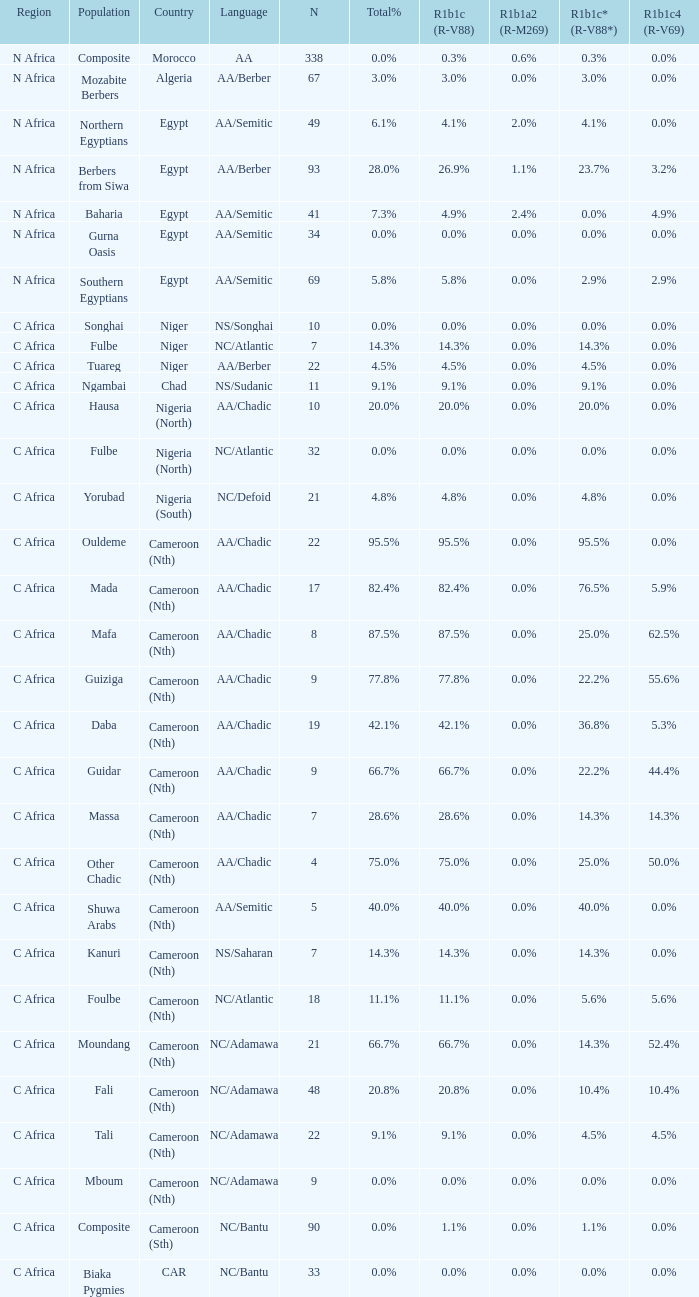What is the number of n listed for berbers from siwa? 1.0. 